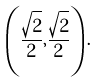<formula> <loc_0><loc_0><loc_500><loc_500>\left ( { \frac { \sqrt { 2 } } { 2 } } , { \frac { \sqrt { 2 } } { 2 } } \right ) .</formula> 